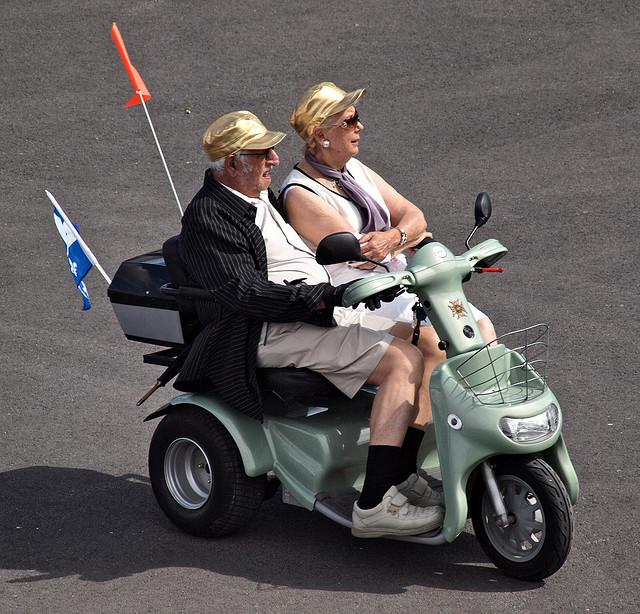Why are two of them on that little vehicle? resting 